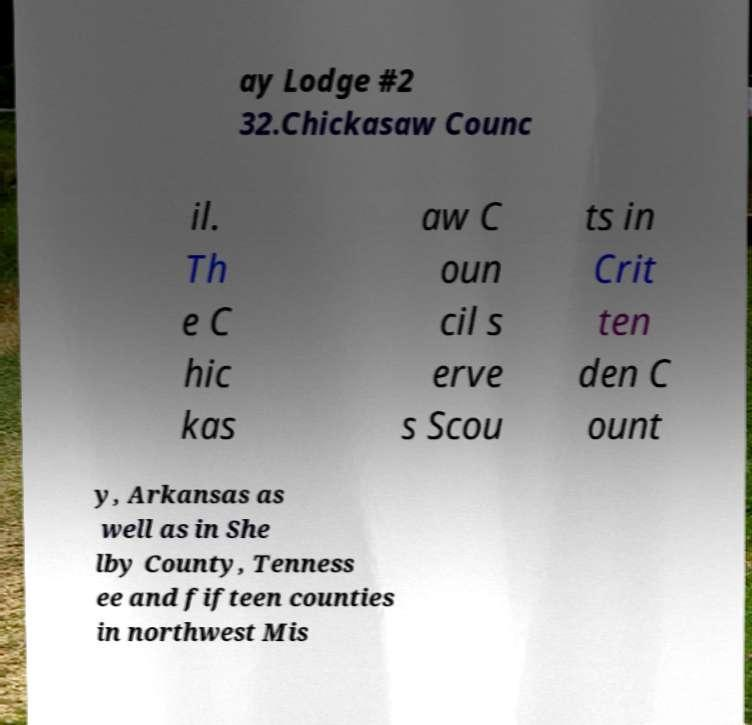What messages or text are displayed in this image? I need them in a readable, typed format. ay Lodge #2 32.Chickasaw Counc il. Th e C hic kas aw C oun cil s erve s Scou ts in Crit ten den C ount y, Arkansas as well as in She lby County, Tenness ee and fifteen counties in northwest Mis 